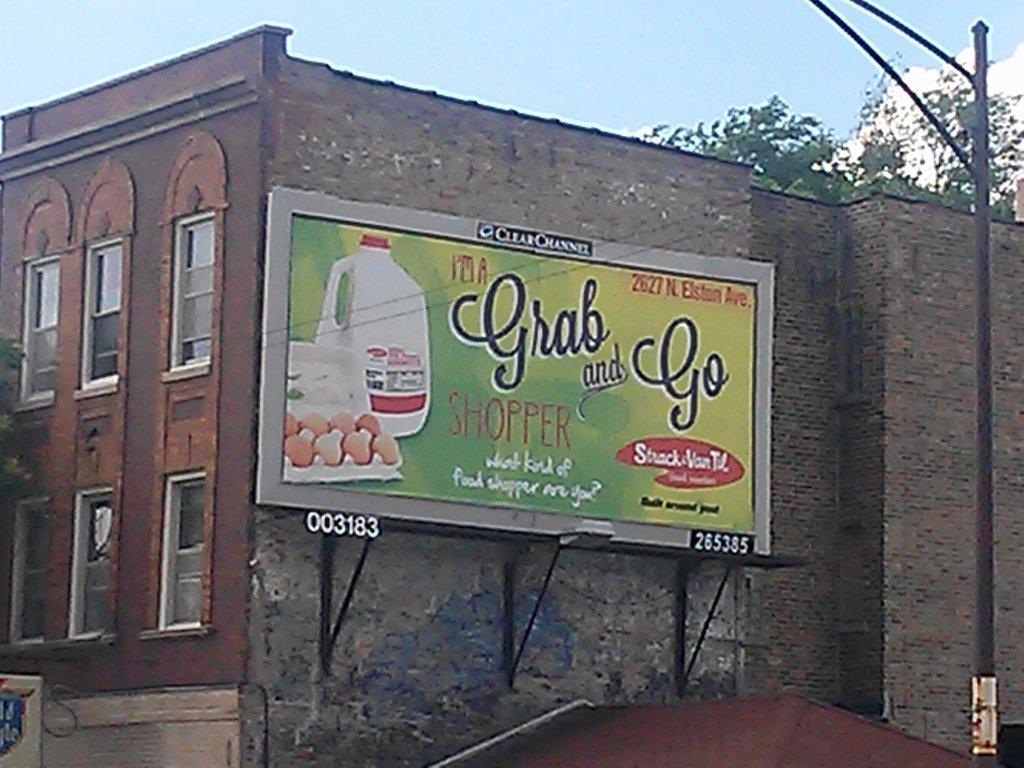<image>
Present a compact description of the photo's key features. a billboard for a grab and go featuring pictures of eggs and milk. 